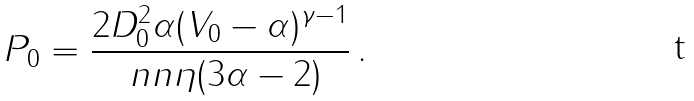<formula> <loc_0><loc_0><loc_500><loc_500>P _ { 0 } = \frac { 2 D _ { 0 } ^ { 2 } \alpha ( V _ { 0 } - \alpha ) ^ { \gamma - 1 } } { \ n n \eta ( 3 \alpha - 2 ) } \, .</formula> 